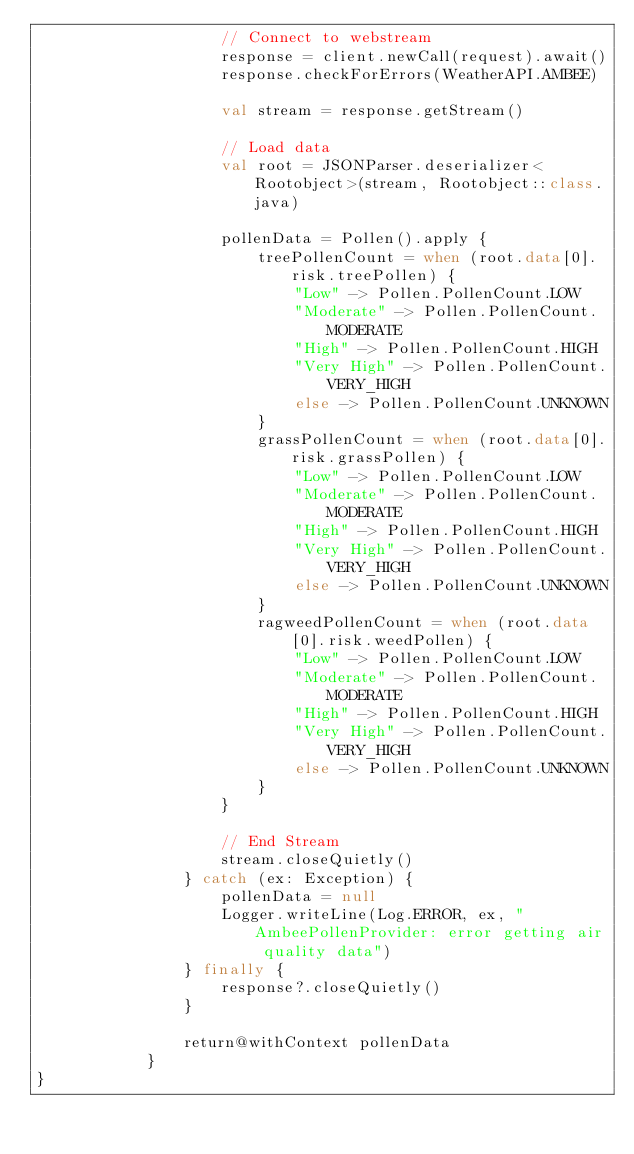Convert code to text. <code><loc_0><loc_0><loc_500><loc_500><_Kotlin_>                    // Connect to webstream
                    response = client.newCall(request).await()
                    response.checkForErrors(WeatherAPI.AMBEE)

                    val stream = response.getStream()

                    // Load data
                    val root = JSONParser.deserializer<Rootobject>(stream, Rootobject::class.java)

                    pollenData = Pollen().apply {
                        treePollenCount = when (root.data[0].risk.treePollen) {
                            "Low" -> Pollen.PollenCount.LOW
                            "Moderate" -> Pollen.PollenCount.MODERATE
                            "High" -> Pollen.PollenCount.HIGH
                            "Very High" -> Pollen.PollenCount.VERY_HIGH
                            else -> Pollen.PollenCount.UNKNOWN
                        }
                        grassPollenCount = when (root.data[0].risk.grassPollen) {
                            "Low" -> Pollen.PollenCount.LOW
                            "Moderate" -> Pollen.PollenCount.MODERATE
                            "High" -> Pollen.PollenCount.HIGH
                            "Very High" -> Pollen.PollenCount.VERY_HIGH
                            else -> Pollen.PollenCount.UNKNOWN
                        }
                        ragweedPollenCount = when (root.data[0].risk.weedPollen) {
                            "Low" -> Pollen.PollenCount.LOW
                            "Moderate" -> Pollen.PollenCount.MODERATE
                            "High" -> Pollen.PollenCount.HIGH
                            "Very High" -> Pollen.PollenCount.VERY_HIGH
                            else -> Pollen.PollenCount.UNKNOWN
                        }
                    }

                    // End Stream
                    stream.closeQuietly()
                } catch (ex: Exception) {
                    pollenData = null
                    Logger.writeLine(Log.ERROR, ex, "AmbeePollenProvider: error getting air quality data")
                } finally {
                    response?.closeQuietly()
                }

                return@withContext pollenData
            }
}</code> 